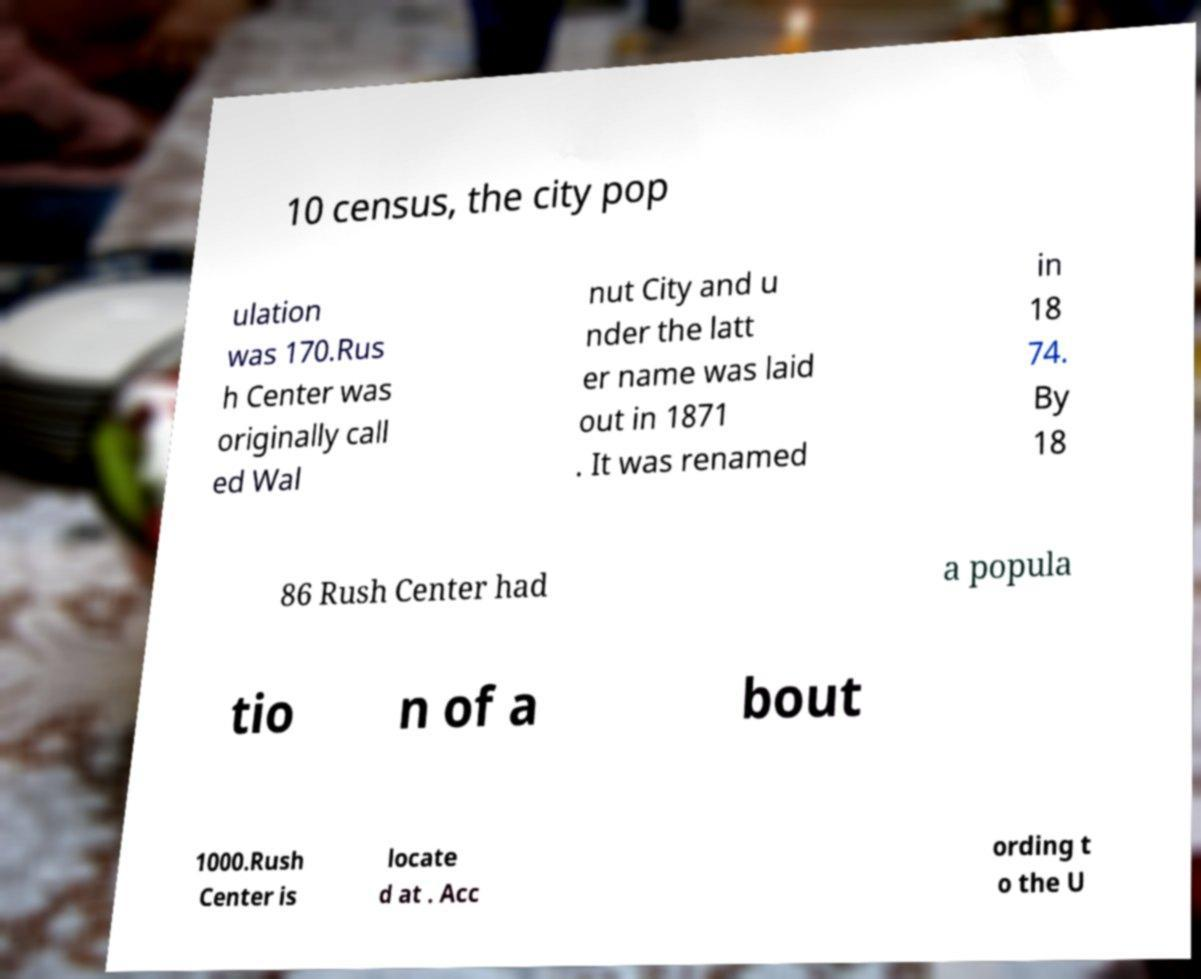Can you read and provide the text displayed in the image?This photo seems to have some interesting text. Can you extract and type it out for me? 10 census, the city pop ulation was 170.Rus h Center was originally call ed Wal nut City and u nder the latt er name was laid out in 1871 . It was renamed in 18 74. By 18 86 Rush Center had a popula tio n of a bout 1000.Rush Center is locate d at . Acc ording t o the U 